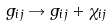Convert formula to latex. <formula><loc_0><loc_0><loc_500><loc_500>g _ { i j } \rightarrow g _ { i j } + \chi _ { i j }</formula> 